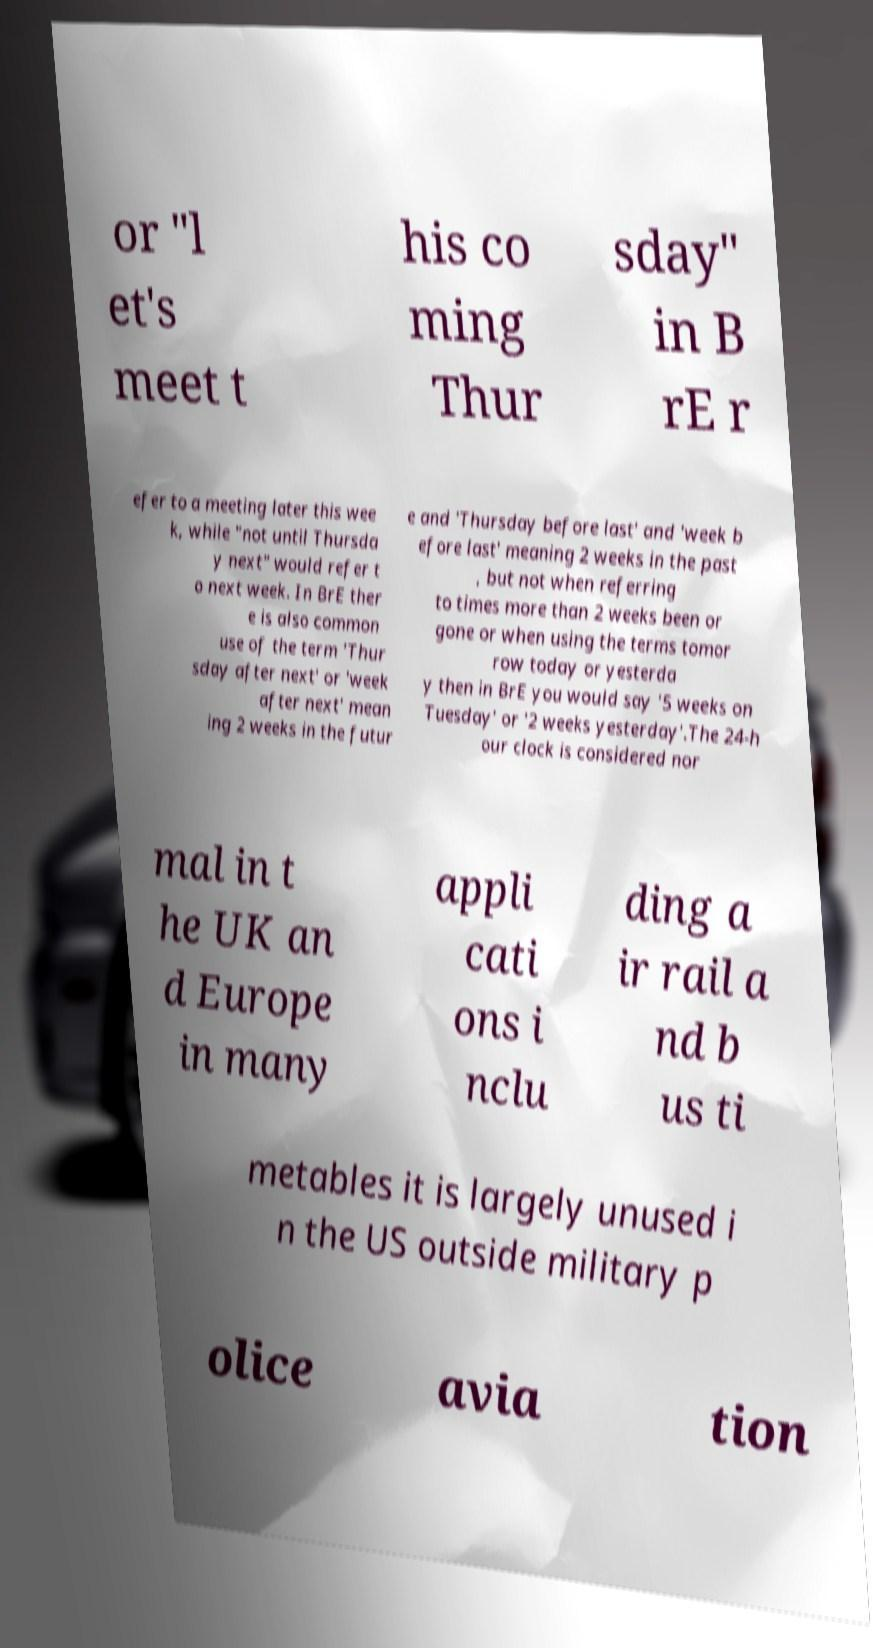I need the written content from this picture converted into text. Can you do that? or "l et's meet t his co ming Thur sday" in B rE r efer to a meeting later this wee k, while "not until Thursda y next" would refer t o next week. In BrE ther e is also common use of the term 'Thur sday after next' or 'week after next' mean ing 2 weeks in the futur e and 'Thursday before last' and 'week b efore last' meaning 2 weeks in the past , but not when referring to times more than 2 weeks been or gone or when using the terms tomor row today or yesterda y then in BrE you would say '5 weeks on Tuesday' or '2 weeks yesterday'.The 24-h our clock is considered nor mal in t he UK an d Europe in many appli cati ons i nclu ding a ir rail a nd b us ti metables it is largely unused i n the US outside military p olice avia tion 